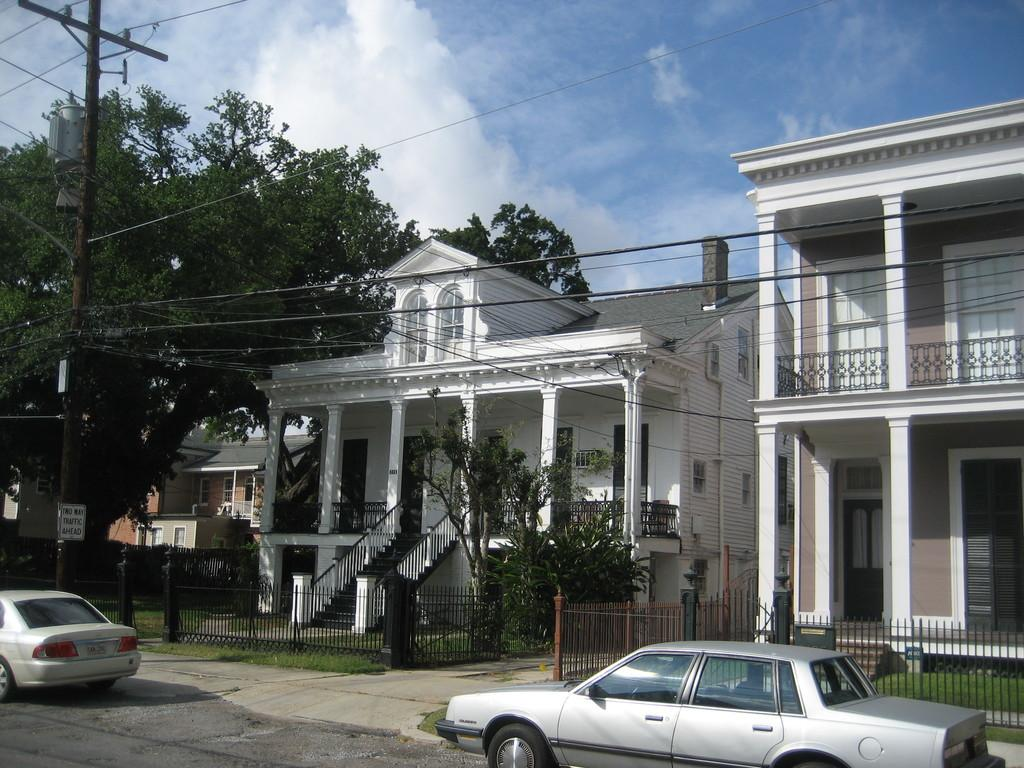What type of vehicles can be seen on the road in the image? There are cars on the road in the image. What structures are visible behind the cars in the image? There are buildings behind the cars in the image. What type of vegetation is present on either side of the road in the image? Trees are present on either side of the road in the image. What is located on the left side of the road in the image? There is an electric pole on the left side of the road in the image. What is visible in the sky in the image? The sky is visible in the image, and clouds are present in the sky. What type of pancake is being served on the trees in the image? There is no pancake present in the image, and trees are not serving any food. 